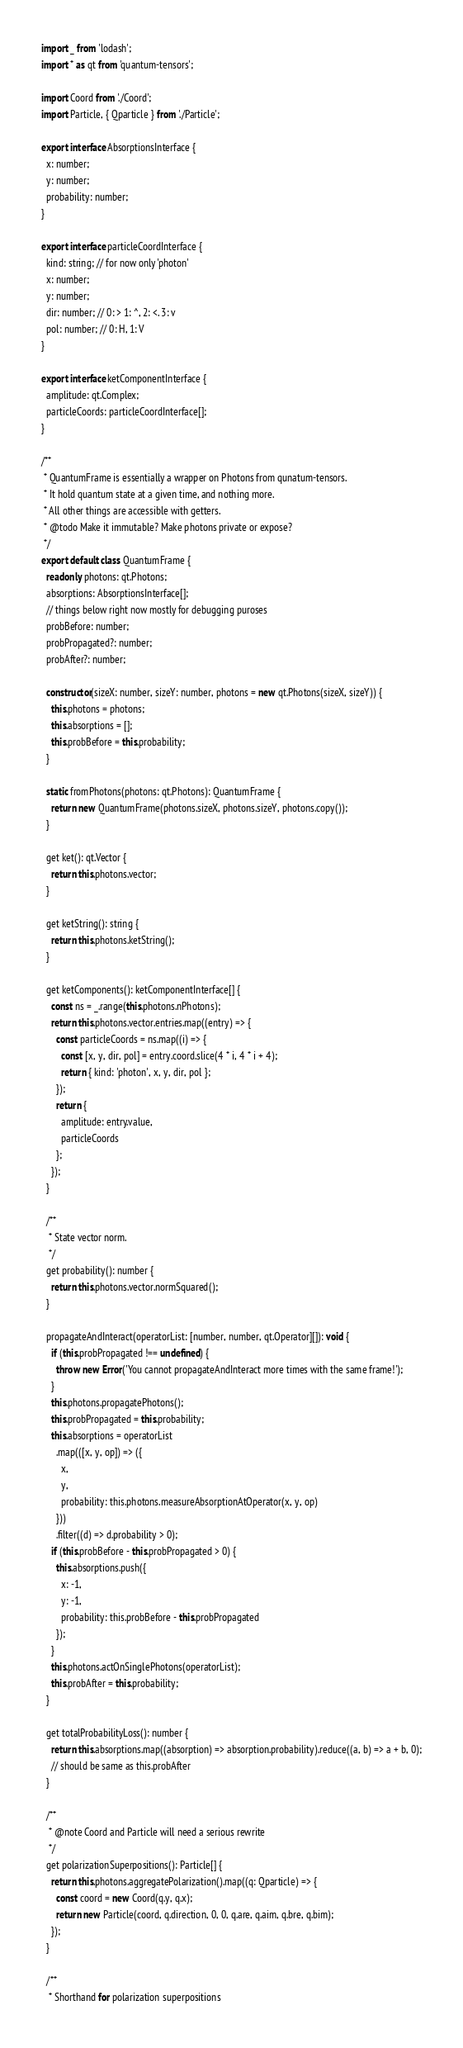Convert code to text. <code><loc_0><loc_0><loc_500><loc_500><_TypeScript_>import _ from 'lodash';
import * as qt from 'quantum-tensors';

import Coord from './Coord';
import Particle, { Qparticle } from './Particle';

export interface AbsorptionsInterface {
  x: number;
  y: number;
  probability: number;
}

export interface particleCoordInterface {
  kind: string; // for now only 'photon'
  x: number;
  y: number;
  dir: number; // 0: > 1: ^, 2: <. 3: v
  pol: number; // 0: H, 1: V
}

export interface ketComponentInterface {
  amplitude: qt.Complex;
  particleCoords: particleCoordInterface[];
}

/**
 * QuantumFrame is essentially a wrapper on Photons from qunatum-tensors.
 * It hold quantum state at a given time, and nothing more.
 * All other things are accessible with getters.
 * @todo Make it immutable? Make photons private or expose?
 */
export default class QuantumFrame {
  readonly photons: qt.Photons;
  absorptions: AbsorptionsInterface[];
  // things below right now mostly for debugging puroses
  probBefore: number;
  probPropagated?: number;
  probAfter?: number;

  constructor(sizeX: number, sizeY: number, photons = new qt.Photons(sizeX, sizeY)) {
    this.photons = photons;
    this.absorptions = [];
    this.probBefore = this.probability;
  }

  static fromPhotons(photons: qt.Photons): QuantumFrame {
    return new QuantumFrame(photons.sizeX, photons.sizeY, photons.copy());
  }

  get ket(): qt.Vector {
    return this.photons.vector;
  }

  get ketString(): string {
    return this.photons.ketString();
  }

  get ketComponents(): ketComponentInterface[] {
    const ns = _.range(this.photons.nPhotons);
    return this.photons.vector.entries.map((entry) => {
      const particleCoords = ns.map((i) => {
        const [x, y, dir, pol] = entry.coord.slice(4 * i, 4 * i + 4);
        return { kind: 'photon', x, y, dir, pol };
      });
      return {
        amplitude: entry.value,
        particleCoords
      };
    });
  }

  /**
   * State vector norm.
   */
  get probability(): number {
    return this.photons.vector.normSquared();
  }

  propagateAndInteract(operatorList: [number, number, qt.Operator][]): void {
    if (this.probPropagated !== undefined) {
      throw new Error('You cannot propagateAndInteract more times with the same frame!');
    }
    this.photons.propagatePhotons();
    this.probPropagated = this.probability;
    this.absorptions = operatorList
      .map(([x, y, op]) => ({
        x,
        y,
        probability: this.photons.measureAbsorptionAtOperator(x, y, op)
      }))
      .filter((d) => d.probability > 0);
    if (this.probBefore - this.probPropagated > 0) {
      this.absorptions.push({
        x: -1,
        y: -1,
        probability: this.probBefore - this.probPropagated
      });
    }
    this.photons.actOnSinglePhotons(operatorList);
    this.probAfter = this.probability;
  }

  get totalProbabilityLoss(): number {
    return this.absorptions.map((absorption) => absorption.probability).reduce((a, b) => a + b, 0);
    // should be same as this.probAfter
  }

  /**
   * @note Coord and Particle will need a serious rewrite
   */
  get polarizationSuperpositions(): Particle[] {
    return this.photons.aggregatePolarization().map((q: Qparticle) => {
      const coord = new Coord(q.y, q.x);
      return new Particle(coord, q.direction, 0, 0, q.are, q.aim, q.bre, q.bim);
    });
  }

  /**
   * Shorthand for polarization superpositions</code> 